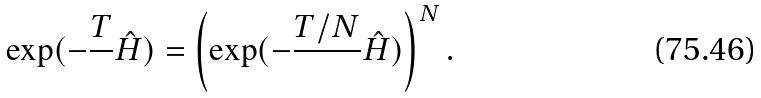Convert formula to latex. <formula><loc_0><loc_0><loc_500><loc_500>\exp ( - \frac { T } { } \hat { H } ) = \left ( \exp ( - \frac { T / N } { } \hat { H } ) \right ) ^ { N } .</formula> 